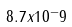<formula> <loc_0><loc_0><loc_500><loc_500>8 . 7 x 1 0 ^ { - } 9</formula> 